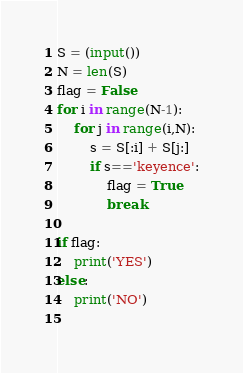Convert code to text. <code><loc_0><loc_0><loc_500><loc_500><_Python_>S = (input())
N = len(S)
flag = False
for i in range(N-1):
    for j in range(i,N):
        s = S[:i] + S[j:]
        if s=='keyence':
            flag = True
            break
        
if flag:
    print('YES')
else:
    print('NO')
    

</code> 